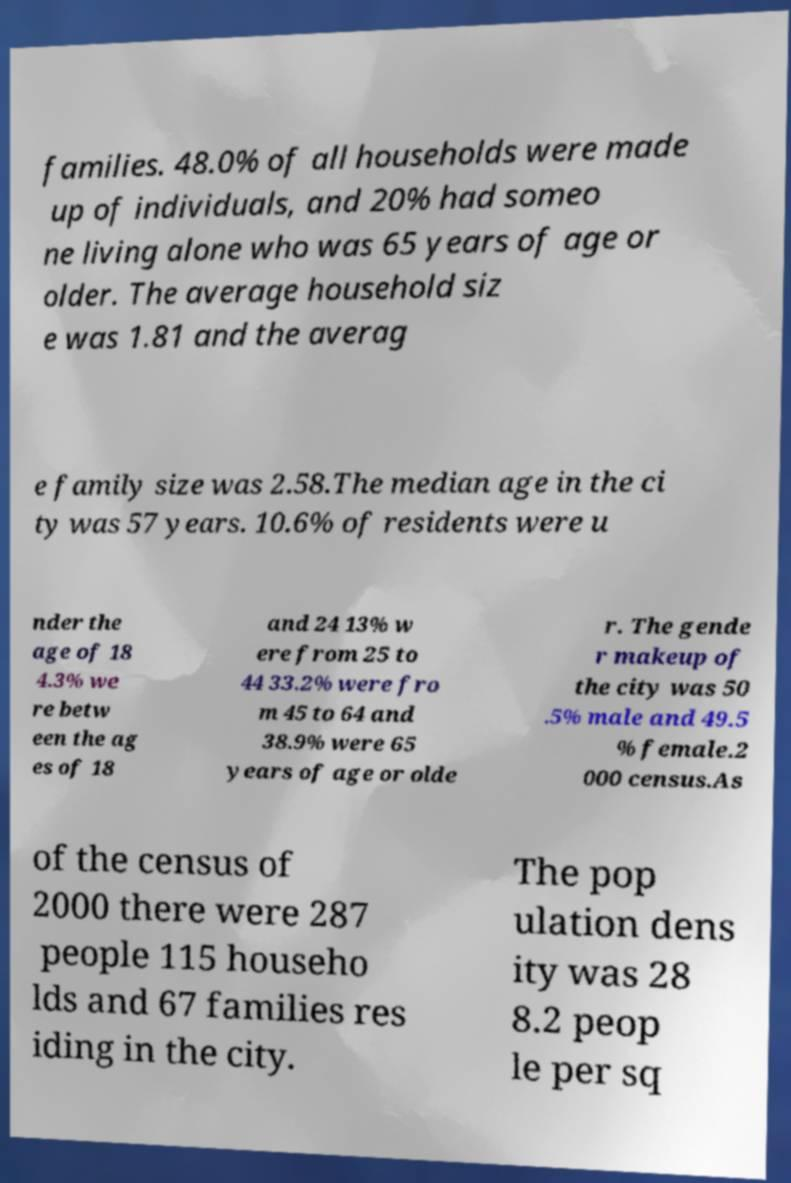Please read and relay the text visible in this image. What does it say? families. 48.0% of all households were made up of individuals, and 20% had someo ne living alone who was 65 years of age or older. The average household siz e was 1.81 and the averag e family size was 2.58.The median age in the ci ty was 57 years. 10.6% of residents were u nder the age of 18 4.3% we re betw een the ag es of 18 and 24 13% w ere from 25 to 44 33.2% were fro m 45 to 64 and 38.9% were 65 years of age or olde r. The gende r makeup of the city was 50 .5% male and 49.5 % female.2 000 census.As of the census of 2000 there were 287 people 115 househo lds and 67 families res iding in the city. The pop ulation dens ity was 28 8.2 peop le per sq 